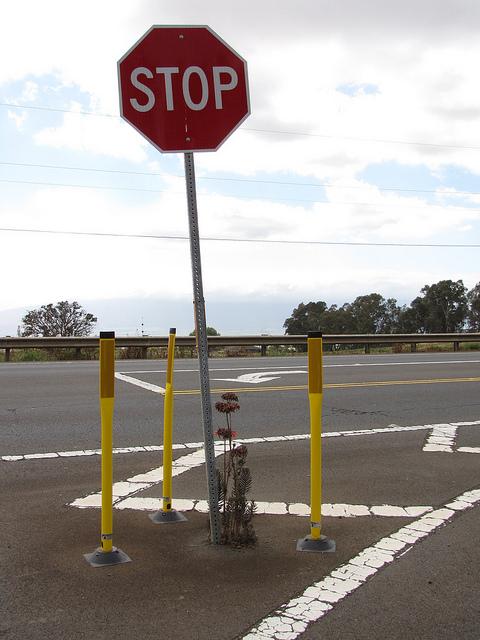What color are the lines painted on the pavement?
Give a very brief answer. White. What does the sign say?
Answer briefly. Stop. How many sides on the sign?
Concise answer only. 8. 